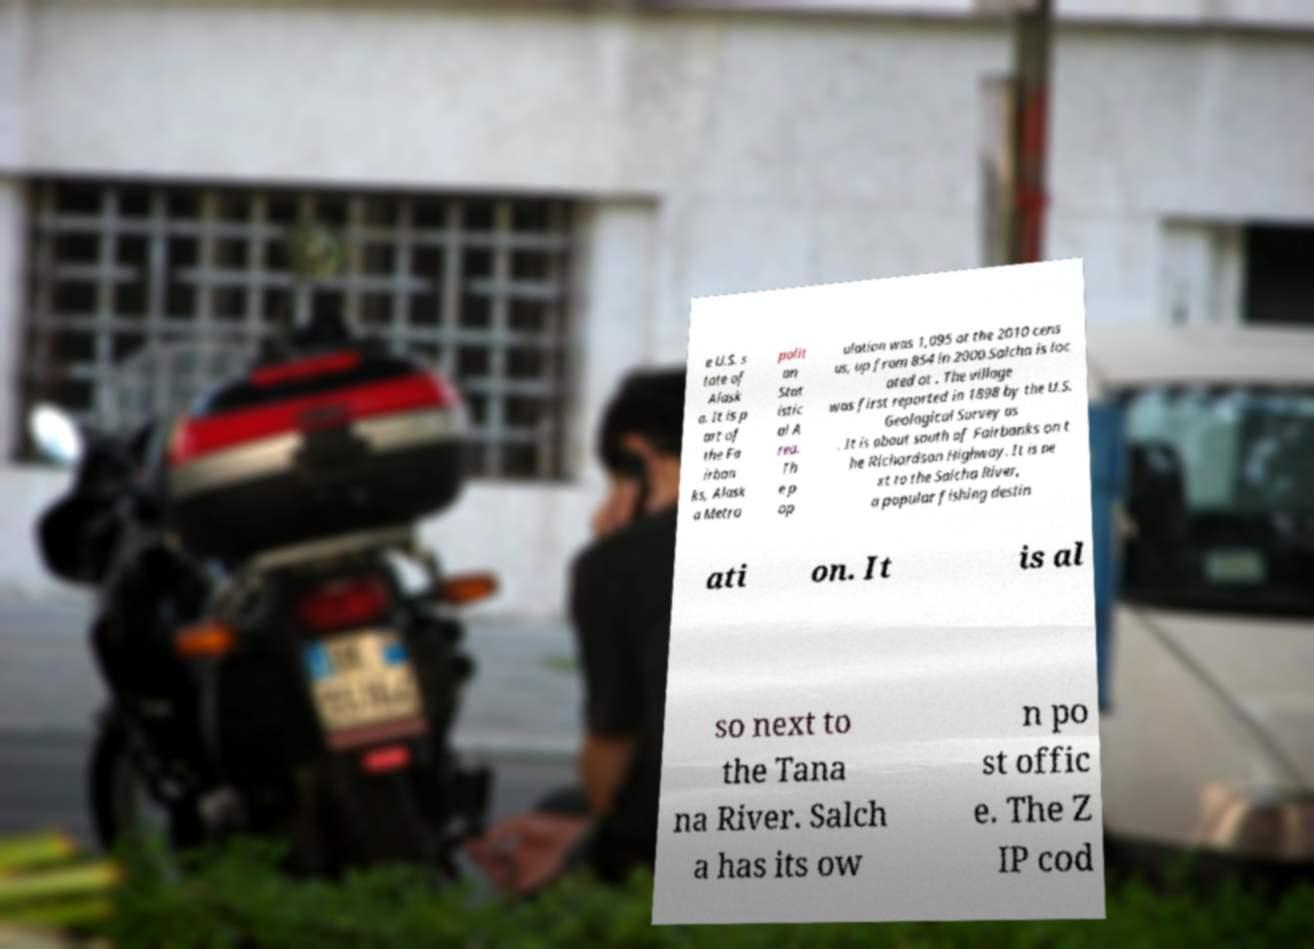I need the written content from this picture converted into text. Can you do that? e U.S. s tate of Alask a. It is p art of the Fa irban ks, Alask a Metro polit an Stat istic al A rea. Th e p op ulation was 1,095 at the 2010 cens us, up from 854 in 2000.Salcha is loc ated at . The village was first reported in 1898 by the U.S. Geological Survey as . It is about south of Fairbanks on t he Richardson Highway. It is ne xt to the Salcha River, a popular fishing destin ati on. It is al so next to the Tana na River. Salch a has its ow n po st offic e. The Z IP cod 